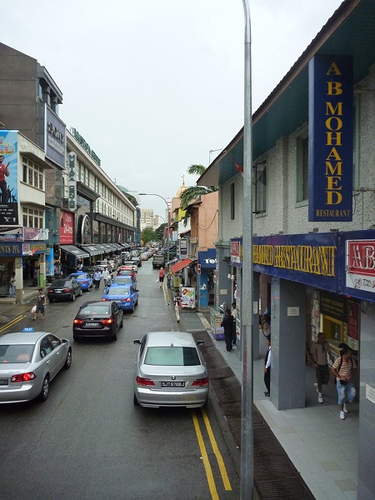<image>
Can you confirm if the car is behind the car? No. The car is not behind the car. From this viewpoint, the car appears to be positioned elsewhere in the scene. Is the car in front of the sign? Yes. The car is positioned in front of the sign, appearing closer to the camera viewpoint. 